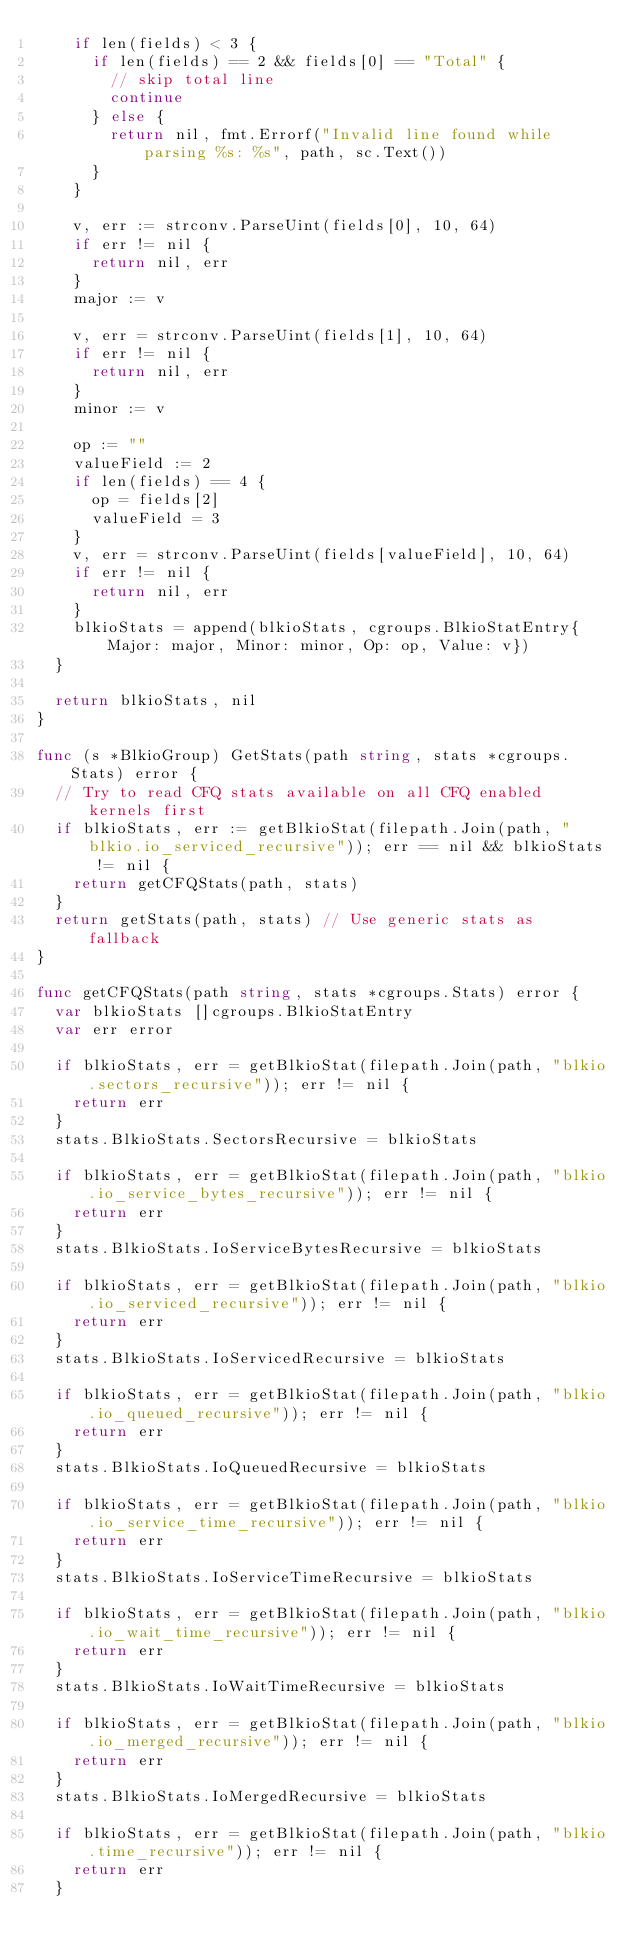<code> <loc_0><loc_0><loc_500><loc_500><_Go_>		if len(fields) < 3 {
			if len(fields) == 2 && fields[0] == "Total" {
				// skip total line
				continue
			} else {
				return nil, fmt.Errorf("Invalid line found while parsing %s: %s", path, sc.Text())
			}
		}

		v, err := strconv.ParseUint(fields[0], 10, 64)
		if err != nil {
			return nil, err
		}
		major := v

		v, err = strconv.ParseUint(fields[1], 10, 64)
		if err != nil {
			return nil, err
		}
		minor := v

		op := ""
		valueField := 2
		if len(fields) == 4 {
			op = fields[2]
			valueField = 3
		}
		v, err = strconv.ParseUint(fields[valueField], 10, 64)
		if err != nil {
			return nil, err
		}
		blkioStats = append(blkioStats, cgroups.BlkioStatEntry{Major: major, Minor: minor, Op: op, Value: v})
	}

	return blkioStats, nil
}

func (s *BlkioGroup) GetStats(path string, stats *cgroups.Stats) error {
	// Try to read CFQ stats available on all CFQ enabled kernels first
	if blkioStats, err := getBlkioStat(filepath.Join(path, "blkio.io_serviced_recursive")); err == nil && blkioStats != nil {
		return getCFQStats(path, stats)
	}
	return getStats(path, stats) // Use generic stats as fallback
}

func getCFQStats(path string, stats *cgroups.Stats) error {
	var blkioStats []cgroups.BlkioStatEntry
	var err error

	if blkioStats, err = getBlkioStat(filepath.Join(path, "blkio.sectors_recursive")); err != nil {
		return err
	}
	stats.BlkioStats.SectorsRecursive = blkioStats

	if blkioStats, err = getBlkioStat(filepath.Join(path, "blkio.io_service_bytes_recursive")); err != nil {
		return err
	}
	stats.BlkioStats.IoServiceBytesRecursive = blkioStats

	if blkioStats, err = getBlkioStat(filepath.Join(path, "blkio.io_serviced_recursive")); err != nil {
		return err
	}
	stats.BlkioStats.IoServicedRecursive = blkioStats

	if blkioStats, err = getBlkioStat(filepath.Join(path, "blkio.io_queued_recursive")); err != nil {
		return err
	}
	stats.BlkioStats.IoQueuedRecursive = blkioStats

	if blkioStats, err = getBlkioStat(filepath.Join(path, "blkio.io_service_time_recursive")); err != nil {
		return err
	}
	stats.BlkioStats.IoServiceTimeRecursive = blkioStats

	if blkioStats, err = getBlkioStat(filepath.Join(path, "blkio.io_wait_time_recursive")); err != nil {
		return err
	}
	stats.BlkioStats.IoWaitTimeRecursive = blkioStats

	if blkioStats, err = getBlkioStat(filepath.Join(path, "blkio.io_merged_recursive")); err != nil {
		return err
	}
	stats.BlkioStats.IoMergedRecursive = blkioStats

	if blkioStats, err = getBlkioStat(filepath.Join(path, "blkio.time_recursive")); err != nil {
		return err
	}</code> 